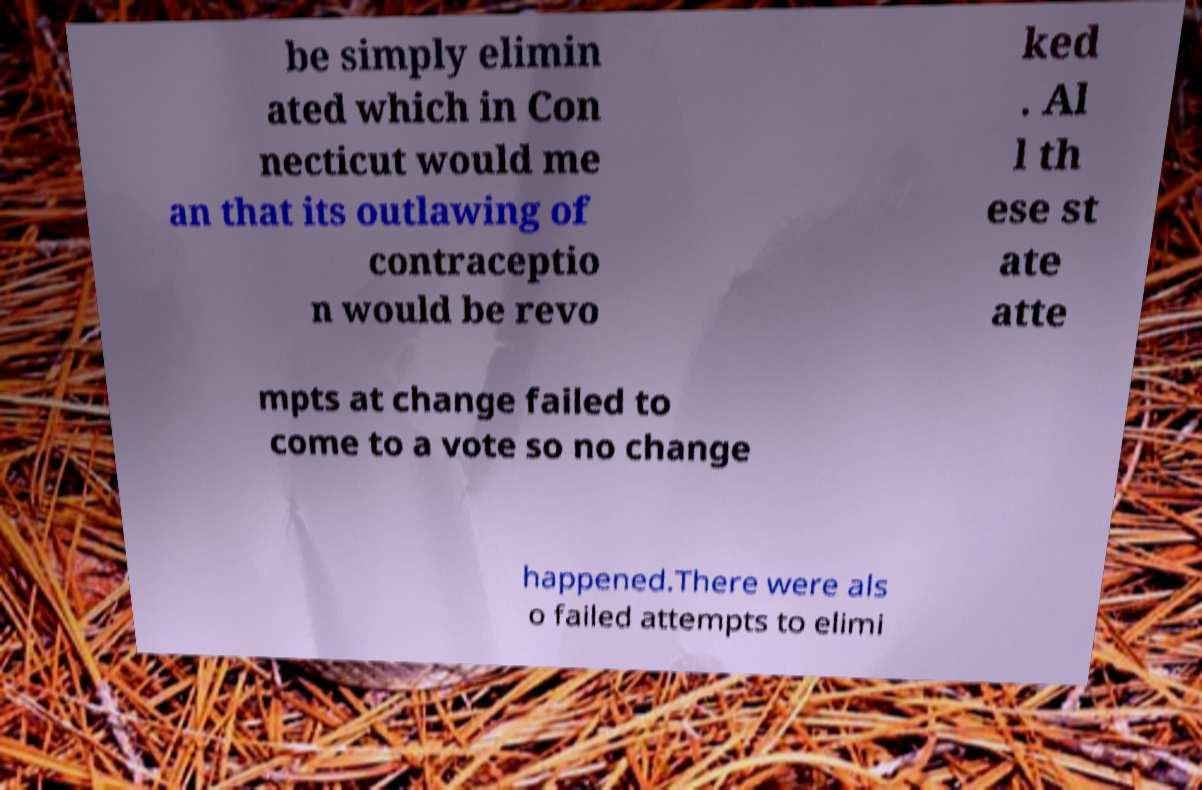There's text embedded in this image that I need extracted. Can you transcribe it verbatim? be simply elimin ated which in Con necticut would me an that its outlawing of contraceptio n would be revo ked . Al l th ese st ate atte mpts at change failed to come to a vote so no change happened.There were als o failed attempts to elimi 